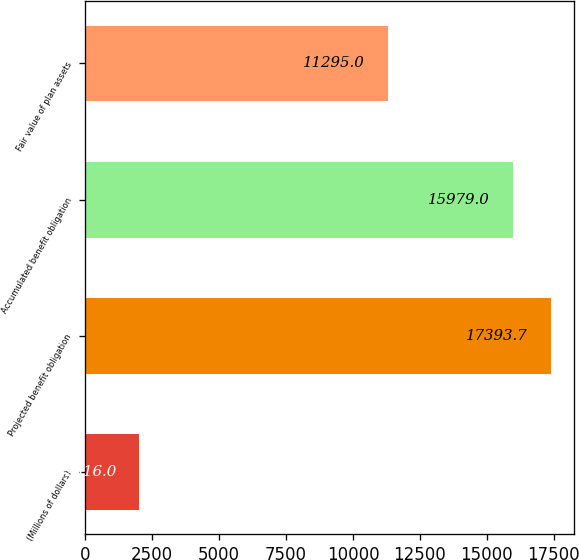<chart> <loc_0><loc_0><loc_500><loc_500><bar_chart><fcel>(Millions of dollars)<fcel>Projected benefit obligation<fcel>Accumulated benefit obligation<fcel>Fair value of plan assets<nl><fcel>2016<fcel>17393.7<fcel>15979<fcel>11295<nl></chart> 